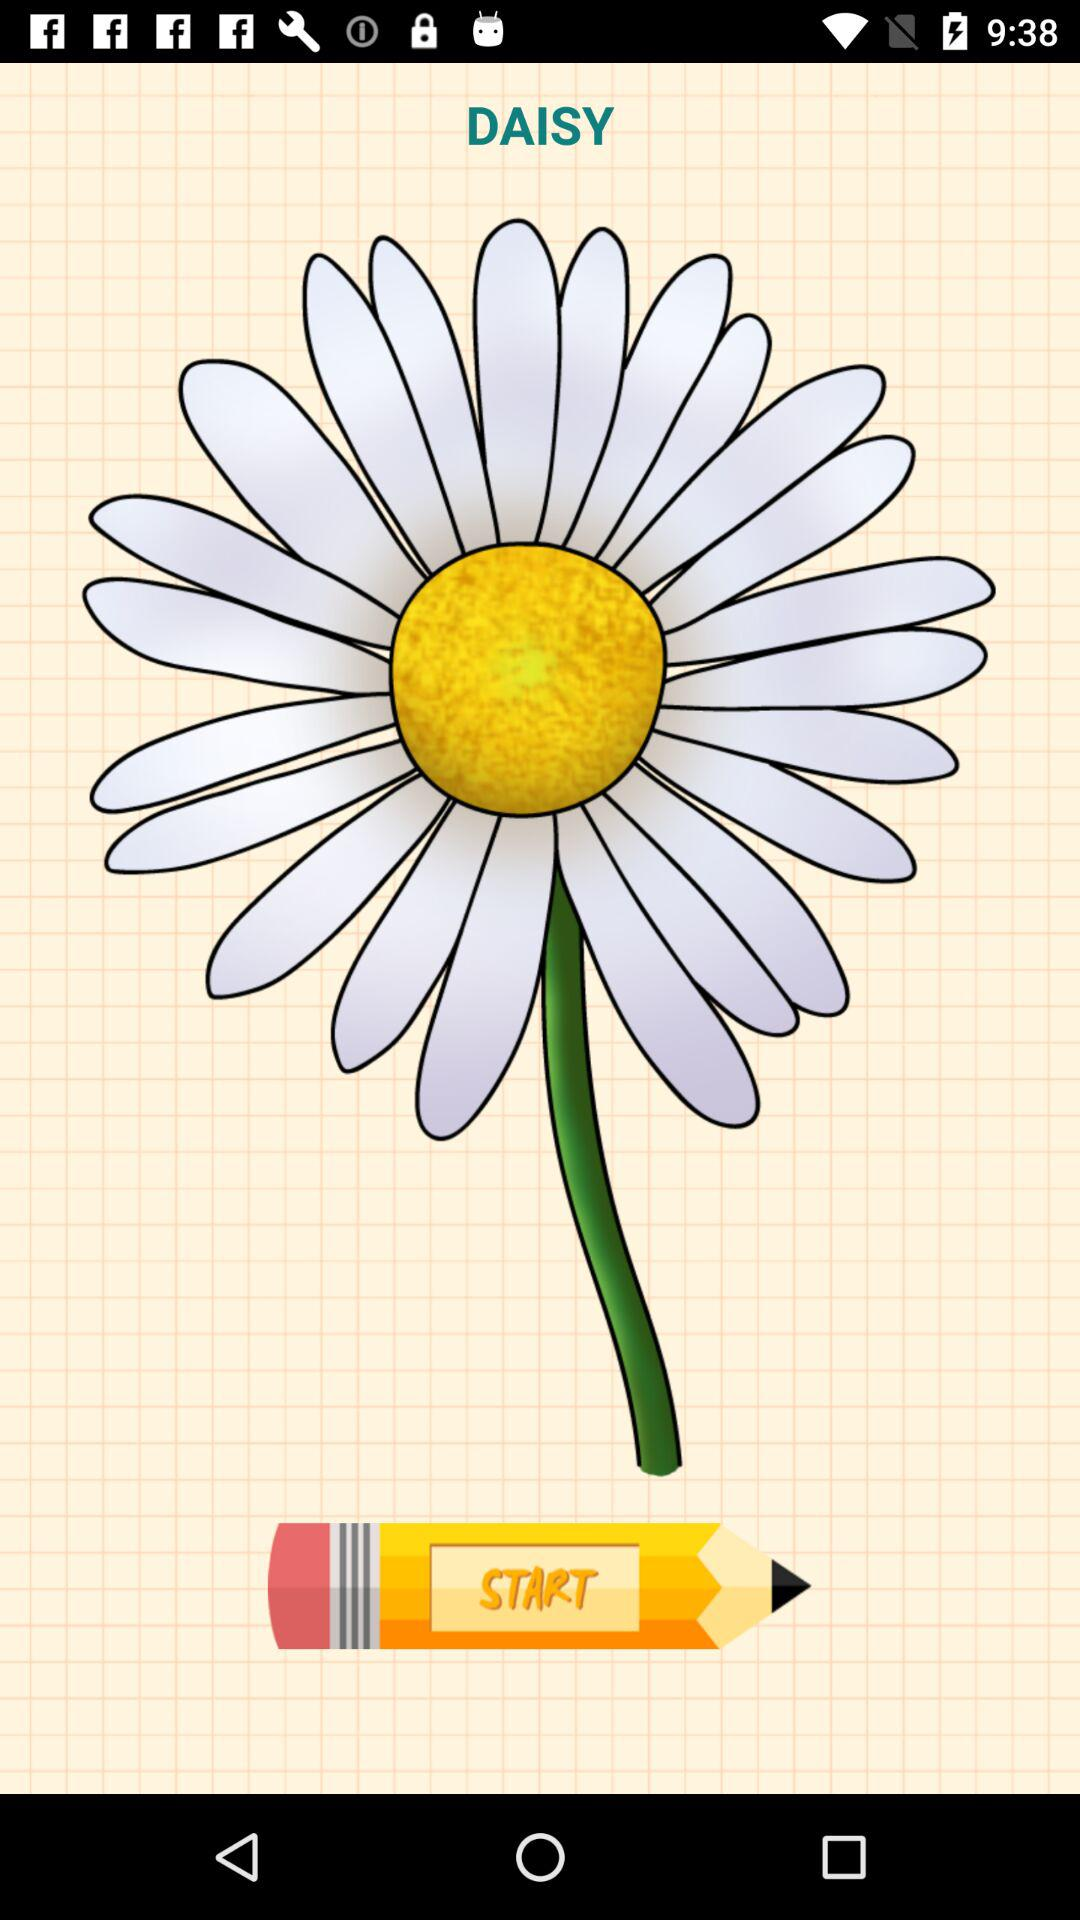Who drew the daisy?
When the provided information is insufficient, respond with <no answer>. <no answer> 